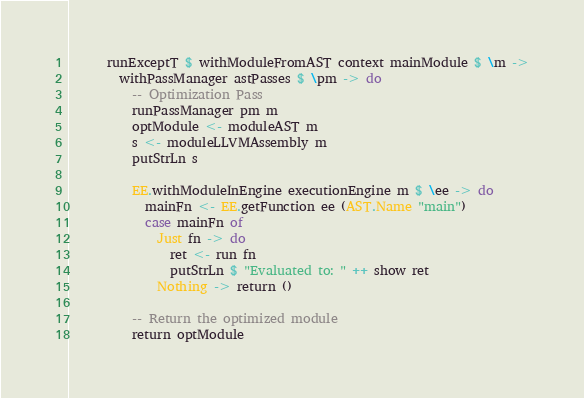<code> <loc_0><loc_0><loc_500><loc_500><_Haskell_>      runExceptT $ withModuleFromAST context mainModule $ \m ->
        withPassManager astPasses $ \pm -> do
          -- Optimization Pass
          runPassManager pm m
          optModule <- moduleAST m
          s <- moduleLLVMAssembly m
          putStrLn s

          EE.withModuleInEngine executionEngine m $ \ee -> do
            mainFn <- EE.getFunction ee (AST.Name "main")
            case mainFn of
              Just fn -> do
                ret <- run fn
                putStrLn $ "Evaluated to: " ++ show ret
              Nothing -> return ()

          -- Return the optimized module
          return optModule
</code> 